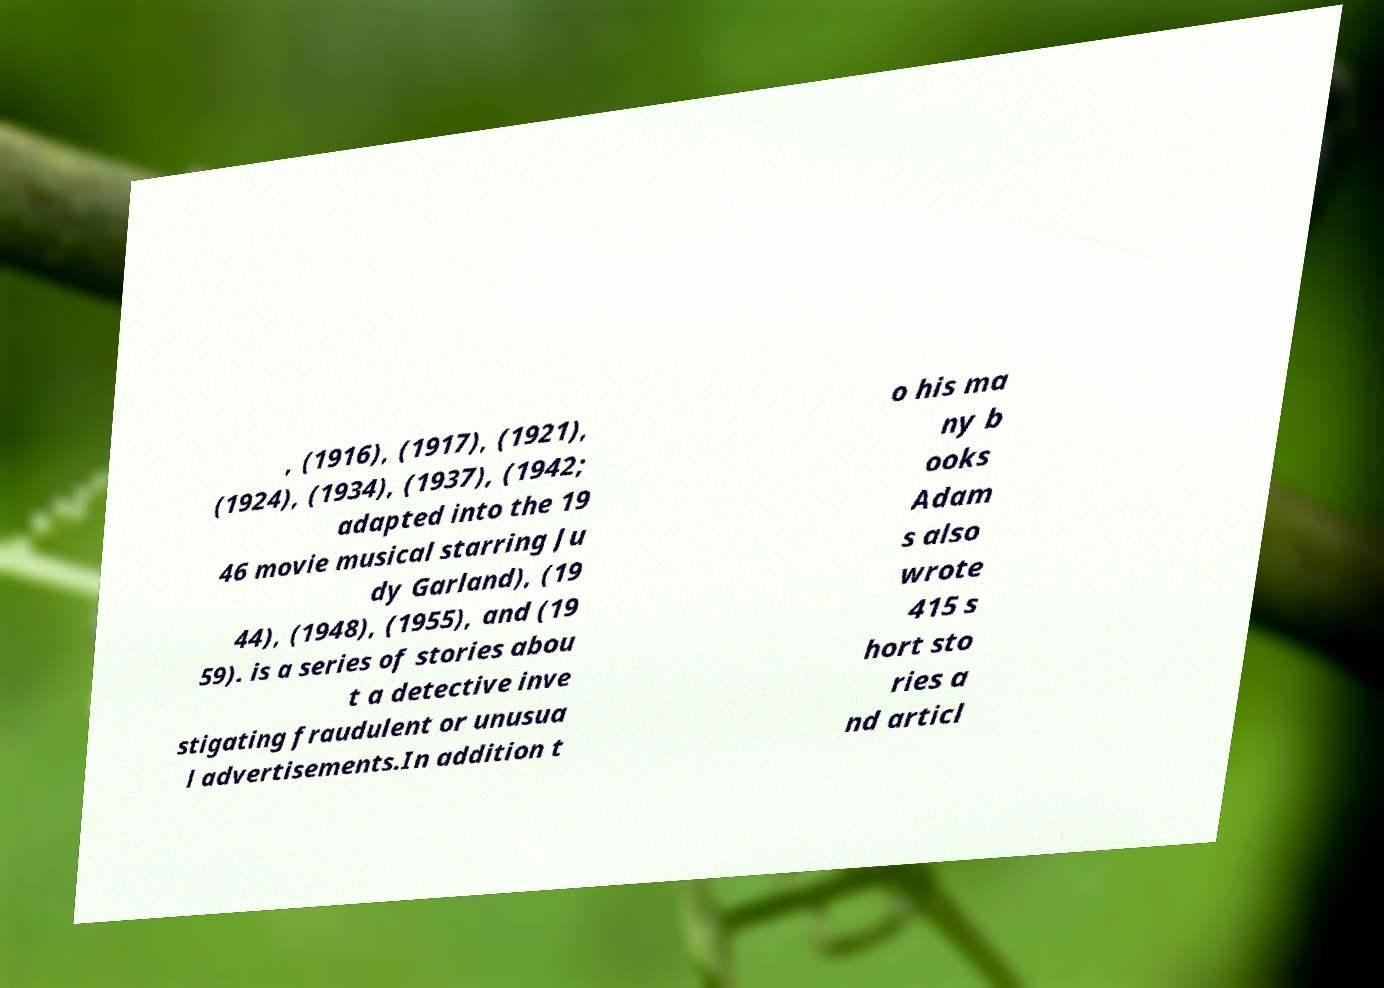Can you read and provide the text displayed in the image?This photo seems to have some interesting text. Can you extract and type it out for me? , (1916), (1917), (1921), (1924), (1934), (1937), (1942; adapted into the 19 46 movie musical starring Ju dy Garland), (19 44), (1948), (1955), and (19 59). is a series of stories abou t a detective inve stigating fraudulent or unusua l advertisements.In addition t o his ma ny b ooks Adam s also wrote 415 s hort sto ries a nd articl 